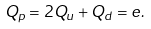<formula> <loc_0><loc_0><loc_500><loc_500>Q _ { p } = 2 Q _ { u } + Q _ { d } = e .</formula> 